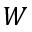Convert formula to latex. <formula><loc_0><loc_0><loc_500><loc_500>W</formula> 